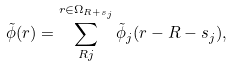Convert formula to latex. <formula><loc_0><loc_0><loc_500><loc_500>\tilde { \phi } ( r ) = \sum _ { R j } ^ { r \in \Omega _ { R + s _ { j } } } \tilde { \phi } _ { j } ( r - R - s _ { j } ) ,</formula> 